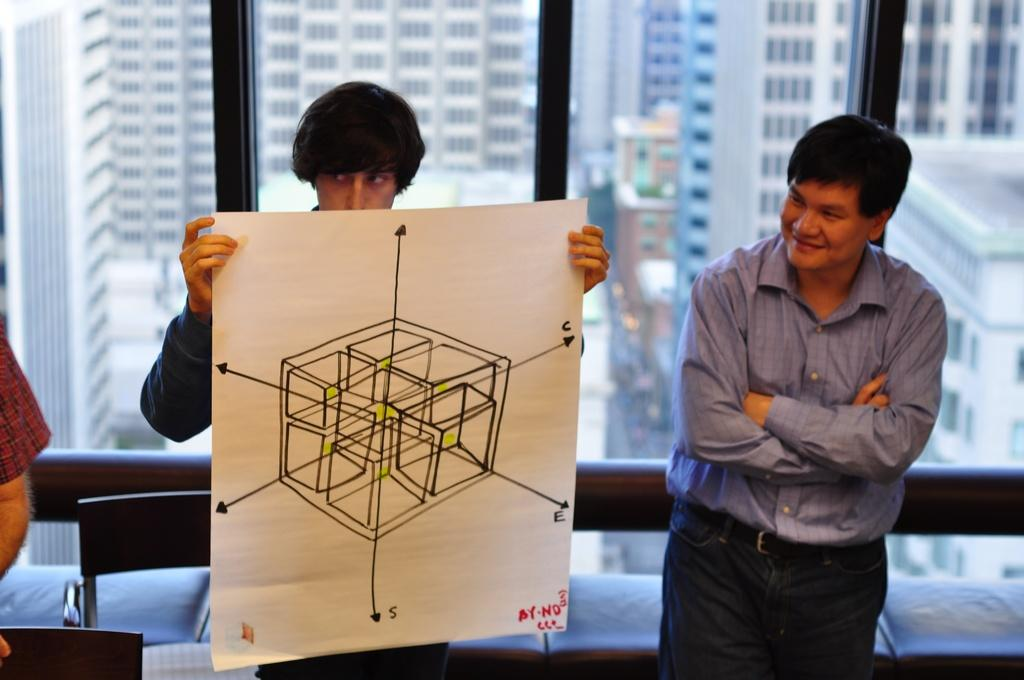How many people are in the image? There are three persons in the image. What is the expression of one of the persons? One of the persons is smiling. What is another person holding in the image? Another person is holding a paper. What can be seen in the background of the image? There are buildings and a window visible in the background. How many dimes can be seen on the person holding the paper? There are no dimes visible on the person holding the paper in the image. Can you describe the badge that the person holding the paper is wearing? There is no badge visible on the person holding the paper in the image. 